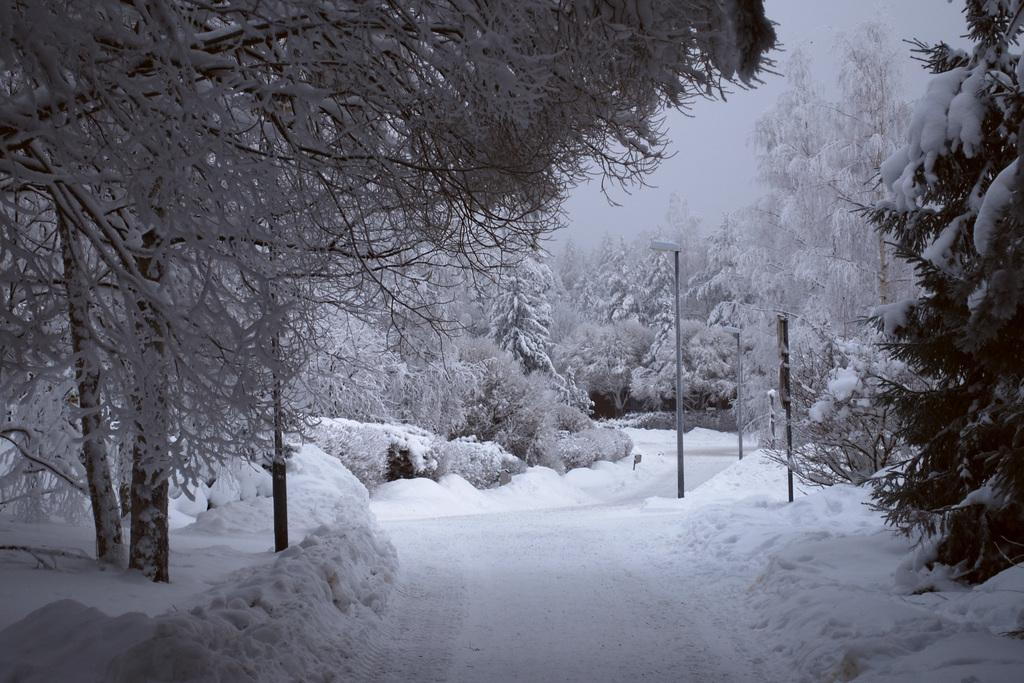What is covering the land in the image? There is snow on the land in the image. What can be seen on both sides of the image? There are trees on either side of the image. What is visible in the middle of the image? There is a path in the middle of the image. Can you see any beans growing on the trees in the image? There are no beans or bean plants visible in the image; the trees are covered in snow. Are there any fairies flying around the trees in the image? There is no mention of fairies or any other mythical creatures in the image; it only features snow-covered trees and a path. 